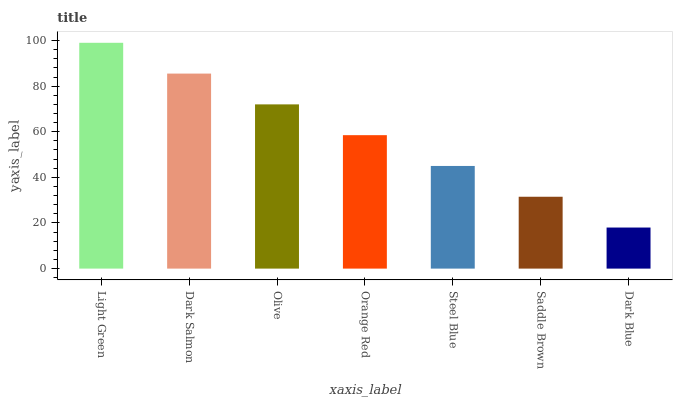Is Dark Blue the minimum?
Answer yes or no. Yes. Is Light Green the maximum?
Answer yes or no. Yes. Is Dark Salmon the minimum?
Answer yes or no. No. Is Dark Salmon the maximum?
Answer yes or no. No. Is Light Green greater than Dark Salmon?
Answer yes or no. Yes. Is Dark Salmon less than Light Green?
Answer yes or no. Yes. Is Dark Salmon greater than Light Green?
Answer yes or no. No. Is Light Green less than Dark Salmon?
Answer yes or no. No. Is Orange Red the high median?
Answer yes or no. Yes. Is Orange Red the low median?
Answer yes or no. Yes. Is Olive the high median?
Answer yes or no. No. Is Dark Blue the low median?
Answer yes or no. No. 